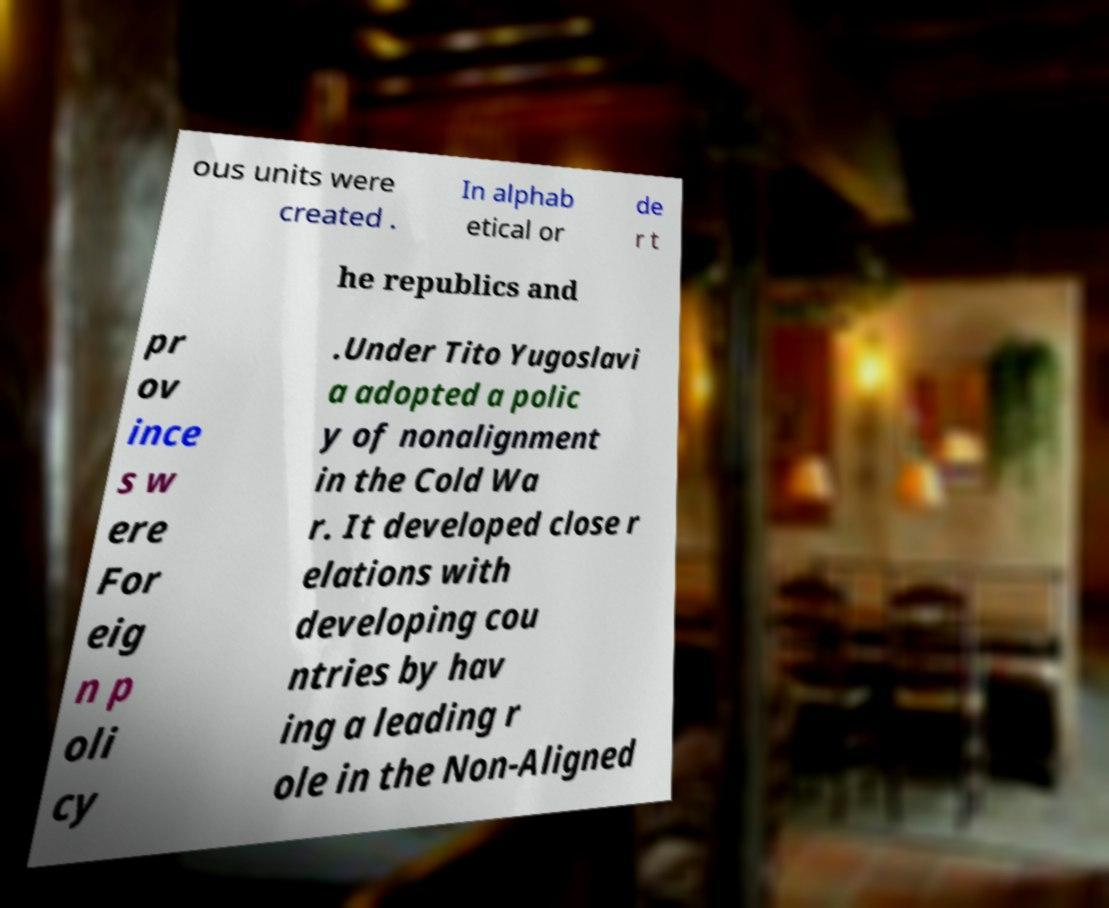Please read and relay the text visible in this image. What does it say? ous units were created . In alphab etical or de r t he republics and pr ov ince s w ere For eig n p oli cy .Under Tito Yugoslavi a adopted a polic y of nonalignment in the Cold Wa r. It developed close r elations with developing cou ntries by hav ing a leading r ole in the Non-Aligned 